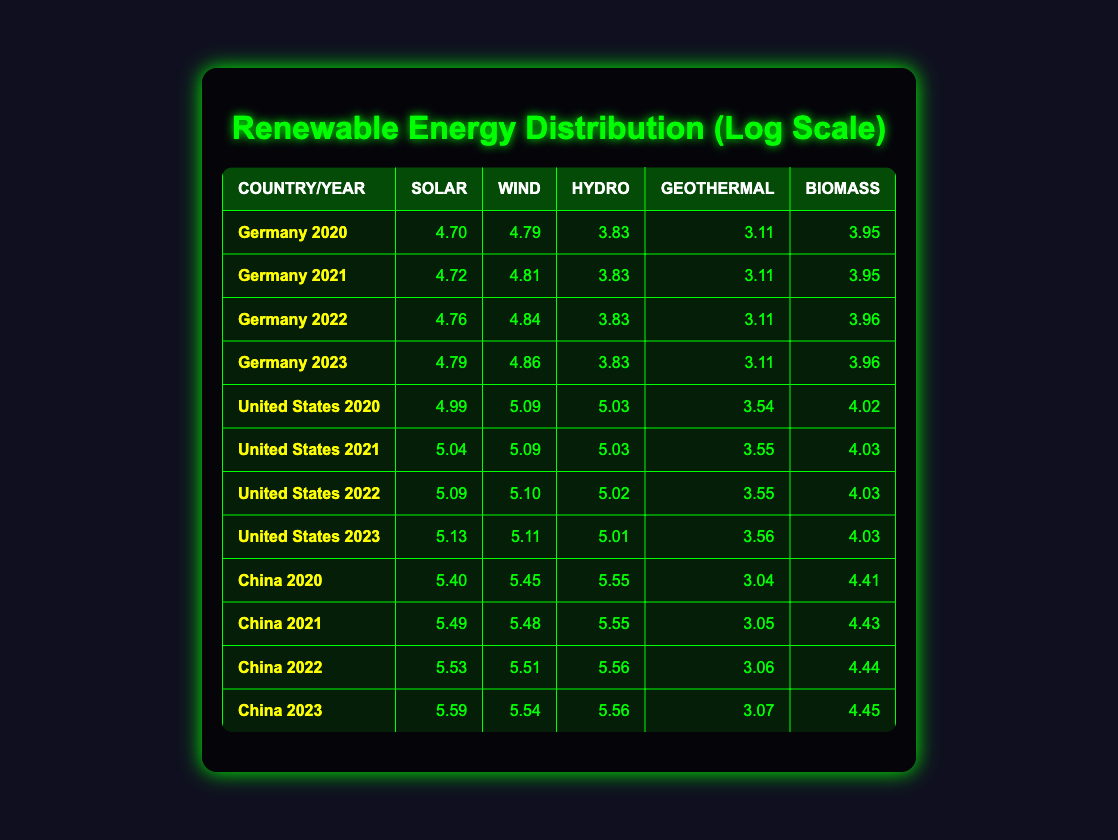What was the solar capacity in Germany in 2023? According to the table, the solar capacity for Germany in 2023 is shown in the relevant row, which indicates a value of 62000 MW.
Answer: 62000 MW Which country had the highest wind capacity in 2022? From the table, by comparing the wind capacities of each country in 2022, it shows that the United States had a wind capacity of 127000 MW, which is higher than Germany's 69945 MW and China's 325000 MW. Therefore, China had the highest wind capacity in 2022.
Answer: China What is the total biomass capacity for the United States in 2021 and 2022? To find the total biomass capacity for the United States in 2021 and 2022, we look at their biomass capacities: in 2021 it was 10600 MW, and in 2022 it was 10700 MW. By adding these two values together: 10600 + 10700 = 21300 MW.
Answer: 21300 MW Is the hydro capacity of China in 2020 higher than Germany's in the same year? The hydro capacity for China in 2020 is 352000 MW, while Germany's capacity is 6784 MW. Since 352000 is significantly greater than 6784, the statement is true.
Answer: Yes What was the trend of solar capacity in Germany from 2020 to 2023? The solar capacity for Germany steadily increased each year: 49750 MW in 2020, 52790 MW in 2021, 58140 MW in 2022, and 62000 MW in 2023. The analysis shows a consistent upward trend throughout these years.
Answer: Increasing trend 